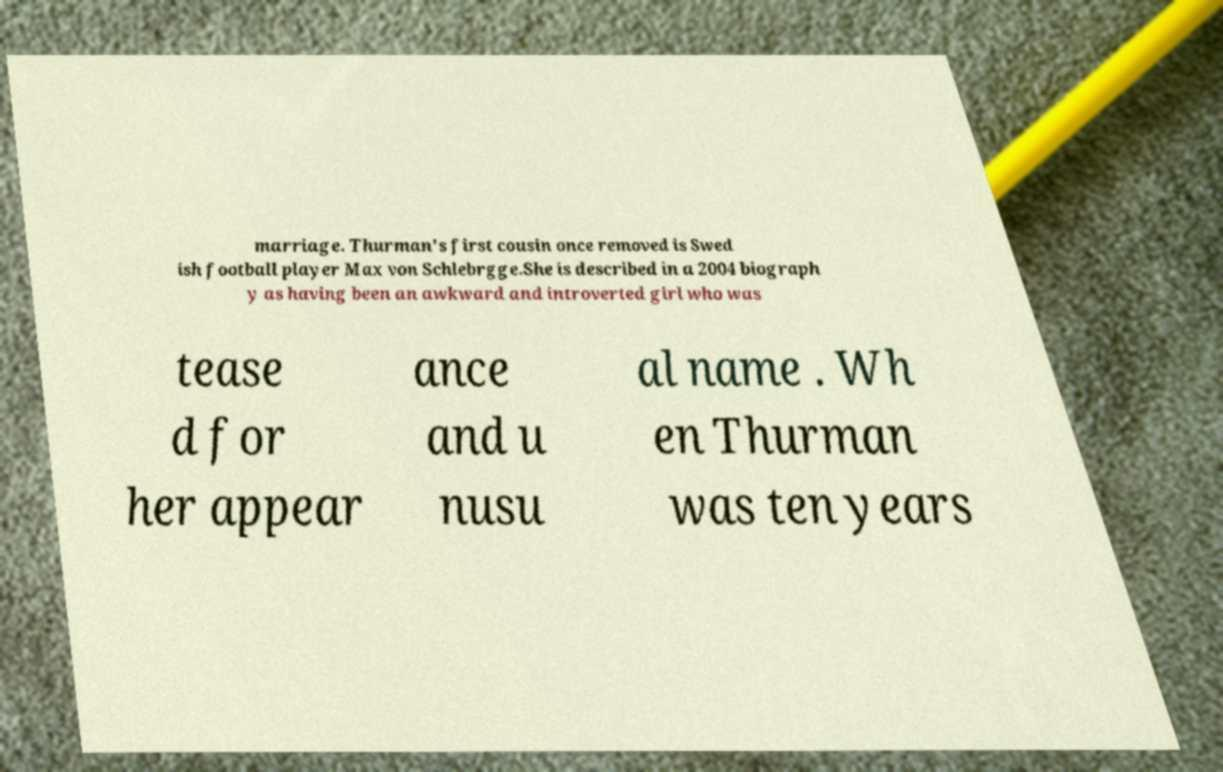Could you assist in decoding the text presented in this image and type it out clearly? marriage. Thurman's first cousin once removed is Swed ish football player Max von Schlebrgge.She is described in a 2004 biograph y as having been an awkward and introverted girl who was tease d for her appear ance and u nusu al name . Wh en Thurman was ten years 